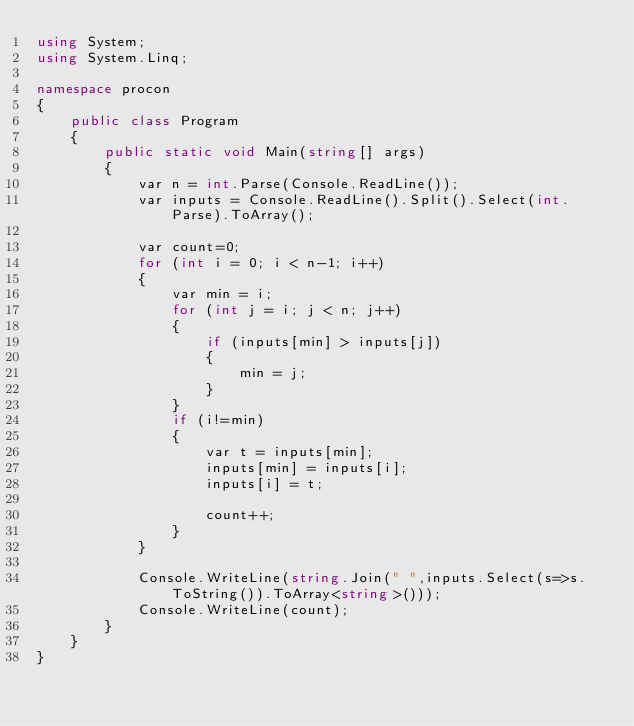Convert code to text. <code><loc_0><loc_0><loc_500><loc_500><_C#_>using System;
using System.Linq;

namespace procon
{
    public class Program
    {
        public static void Main(string[] args)
        {
            var n = int.Parse(Console.ReadLine());
            var inputs = Console.ReadLine().Split().Select(int.Parse).ToArray();

            var count=0;
            for (int i = 0; i < n-1; i++)
            {
                var min = i;
                for (int j = i; j < n; j++)
                {
                    if (inputs[min] > inputs[j])
                    {
                        min = j;
                    }
                }
                if (i!=min)
                {
                    var t = inputs[min];
                    inputs[min] = inputs[i];
                    inputs[i] = t;

                    count++;
                }
            }

            Console.WriteLine(string.Join(" ",inputs.Select(s=>s.ToString()).ToArray<string>()));
            Console.WriteLine(count);
        }
    }
}</code> 